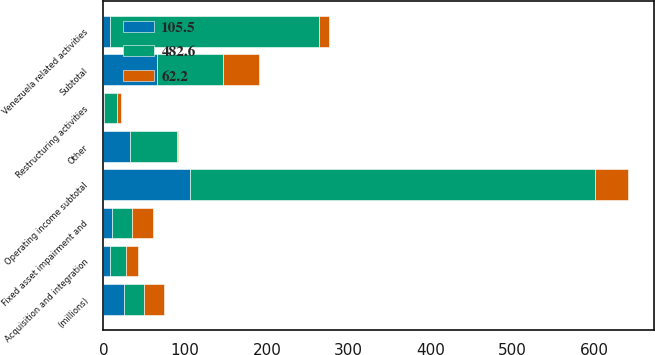<chart> <loc_0><loc_0><loc_500><loc_500><stacked_bar_chart><ecel><fcel>(millions)<fcel>Restructuring activities<fcel>Fixed asset impairment and<fcel>Subtotal<fcel>Acquisition and integration<fcel>Venezuela related activities<fcel>Other<fcel>Operating income subtotal<nl><fcel>62.2<fcel>24.7<fcel>4.6<fcel>26.2<fcel>44<fcel>15.4<fcel>11.5<fcel>1.4<fcel>40.3<nl><fcel>105.5<fcel>24.7<fcel>0.4<fcel>10<fcel>66<fcel>8.6<fcel>7.8<fcel>33.2<fcel>105.5<nl><fcel>482.6<fcel>24.7<fcel>16.5<fcel>24.7<fcel>80.6<fcel>18.7<fcel>256<fcel>56.3<fcel>495.4<nl></chart> 